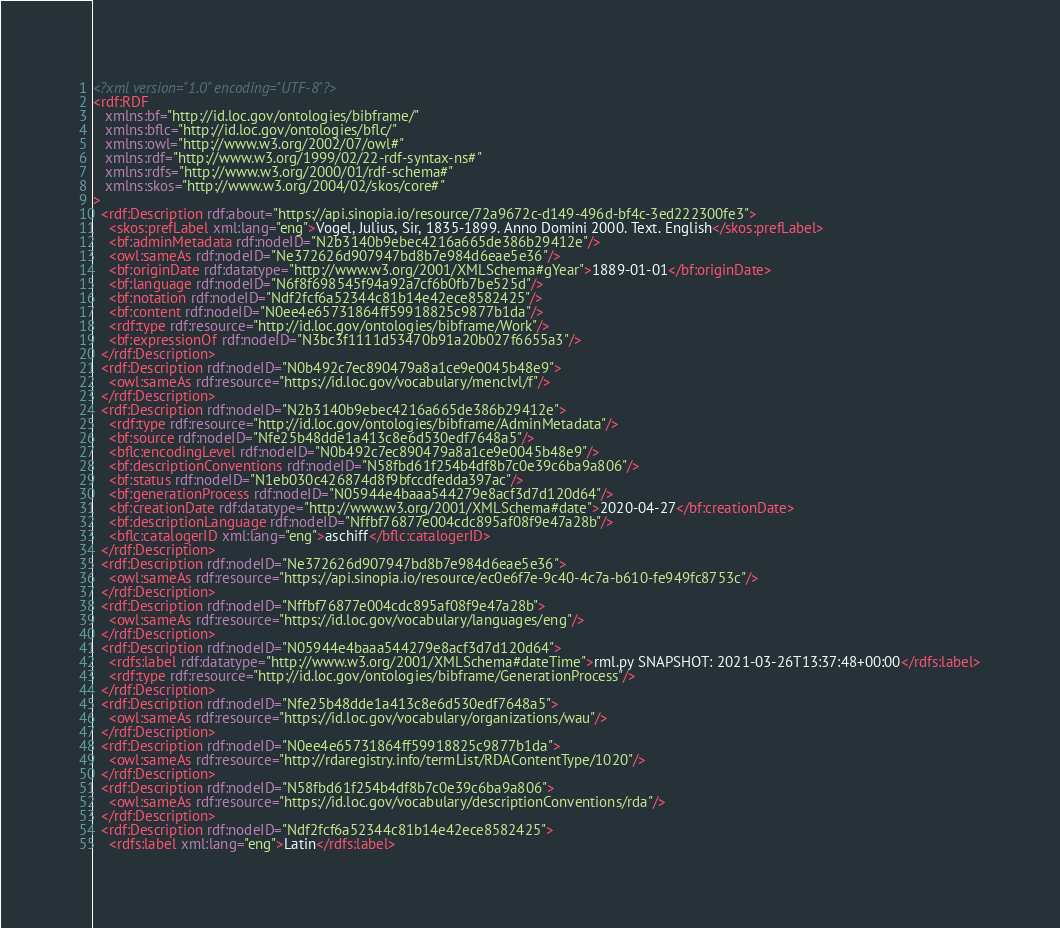<code> <loc_0><loc_0><loc_500><loc_500><_XML_><?xml version="1.0" encoding="UTF-8"?>
<rdf:RDF
   xmlns:bf="http://id.loc.gov/ontologies/bibframe/"
   xmlns:bflc="http://id.loc.gov/ontologies/bflc/"
   xmlns:owl="http://www.w3.org/2002/07/owl#"
   xmlns:rdf="http://www.w3.org/1999/02/22-rdf-syntax-ns#"
   xmlns:rdfs="http://www.w3.org/2000/01/rdf-schema#"
   xmlns:skos="http://www.w3.org/2004/02/skos/core#"
>
  <rdf:Description rdf:about="https://api.sinopia.io/resource/72a9672c-d149-496d-bf4c-3ed222300fe3">
    <skos:prefLabel xml:lang="eng">Vogel, Julius, Sir, 1835-1899. Anno Domini 2000. Text. English</skos:prefLabel>
    <bf:adminMetadata rdf:nodeID="N2b3140b9ebec4216a665de386b29412e"/>
    <owl:sameAs rdf:nodeID="Ne372626d907947bd8b7e984d6eae5e36"/>
    <bf:originDate rdf:datatype="http://www.w3.org/2001/XMLSchema#gYear">1889-01-01</bf:originDate>
    <bf:language rdf:nodeID="N6f8f698545f94a92a7cf6b0fb7be525d"/>
    <bf:notation rdf:nodeID="Ndf2fcf6a52344c81b14e42ece8582425"/>
    <bf:content rdf:nodeID="N0ee4e65731864ff59918825c9877b1da"/>
    <rdf:type rdf:resource="http://id.loc.gov/ontologies/bibframe/Work"/>
    <bf:expressionOf rdf:nodeID="N3bc3f1111d53470b91a20b027f6655a3"/>
  </rdf:Description>
  <rdf:Description rdf:nodeID="N0b492c7ec890479a8a1ce9e0045b48e9">
    <owl:sameAs rdf:resource="https://id.loc.gov/vocabulary/menclvl/f"/>
  </rdf:Description>
  <rdf:Description rdf:nodeID="N2b3140b9ebec4216a665de386b29412e">
    <rdf:type rdf:resource="http://id.loc.gov/ontologies/bibframe/AdminMetadata"/>
    <bf:source rdf:nodeID="Nfe25b48dde1a413c8e6d530edf7648a5"/>
    <bflc:encodingLevel rdf:nodeID="N0b492c7ec890479a8a1ce9e0045b48e9"/>
    <bf:descriptionConventions rdf:nodeID="N58fbd61f254b4df8b7c0e39c6ba9a806"/>
    <bf:status rdf:nodeID="N1eb030c426874d8f9bfccdfedda397ac"/>
    <bf:generationProcess rdf:nodeID="N05944e4baaa544279e8acf3d7d120d64"/>
    <bf:creationDate rdf:datatype="http://www.w3.org/2001/XMLSchema#date">2020-04-27</bf:creationDate>
    <bf:descriptionLanguage rdf:nodeID="Nffbf76877e004cdc895af08f9e47a28b"/>
    <bflc:catalogerID xml:lang="eng">aschiff</bflc:catalogerID>
  </rdf:Description>
  <rdf:Description rdf:nodeID="Ne372626d907947bd8b7e984d6eae5e36">
    <owl:sameAs rdf:resource="https://api.sinopia.io/resource/ec0e6f7e-9c40-4c7a-b610-fe949fc8753c"/>
  </rdf:Description>
  <rdf:Description rdf:nodeID="Nffbf76877e004cdc895af08f9e47a28b">
    <owl:sameAs rdf:resource="https://id.loc.gov/vocabulary/languages/eng"/>
  </rdf:Description>
  <rdf:Description rdf:nodeID="N05944e4baaa544279e8acf3d7d120d64">
    <rdfs:label rdf:datatype="http://www.w3.org/2001/XMLSchema#dateTime">rml.py SNAPSHOT: 2021-03-26T13:37:48+00:00</rdfs:label>
    <rdf:type rdf:resource="http://id.loc.gov/ontologies/bibframe/GenerationProcess"/>
  </rdf:Description>
  <rdf:Description rdf:nodeID="Nfe25b48dde1a413c8e6d530edf7648a5">
    <owl:sameAs rdf:resource="https://id.loc.gov/vocabulary/organizations/wau"/>
  </rdf:Description>
  <rdf:Description rdf:nodeID="N0ee4e65731864ff59918825c9877b1da">
    <owl:sameAs rdf:resource="http://rdaregistry.info/termList/RDAContentType/1020"/>
  </rdf:Description>
  <rdf:Description rdf:nodeID="N58fbd61f254b4df8b7c0e39c6ba9a806">
    <owl:sameAs rdf:resource="https://id.loc.gov/vocabulary/descriptionConventions/rda"/>
  </rdf:Description>
  <rdf:Description rdf:nodeID="Ndf2fcf6a52344c81b14e42ece8582425">
    <rdfs:label xml:lang="eng">Latin</rdfs:label></code> 